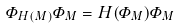Convert formula to latex. <formula><loc_0><loc_0><loc_500><loc_500>\varPhi _ { H ( M ) } \varPhi _ { M } = H ( \varPhi _ { M } ) \varPhi _ { M }</formula> 